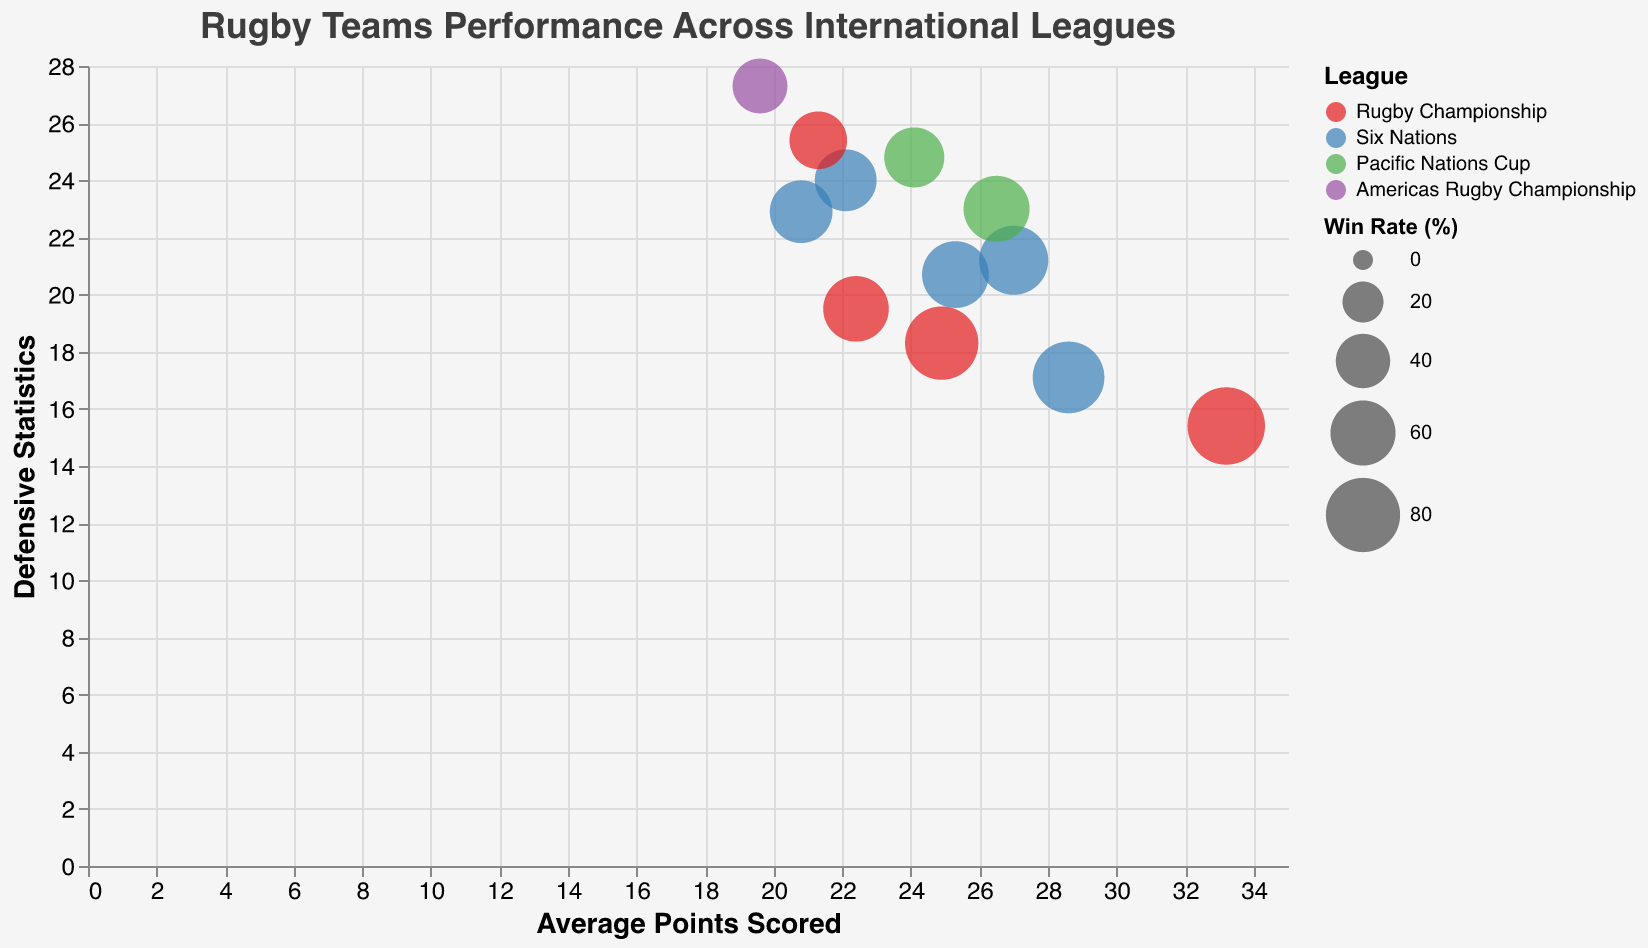What's the title of the chart? The title of the chart is usually located at the top. In this case, it is clearly labeled.
Answer: Rugby Teams Performance Across International Leagues Which league does the color red represent in the chart? The chart uses specific colors to indicate different leagues. Red represents one of these leagues according to the legend.
Answer: Rugby Championship What is the average win rate of teams in the Six Nations league displayed on the chart? To find the average win rate, sum the win rates of all the teams in the Six Nations league and divide by the number of teams: (74.2 + 63.5 + 68.4 + 55.3 + 53.5)/5 = 62.98%.
Answer: 62.98% Which team has the highest win rate and what is it? The largest bubble will indicate the highest win rate. Based on the data, this team is the New Zealand All Blacks.
Answer: New Zealand All Blacks with 87.5% Compare the defensive statistics of the Fiji Flying Fijians and the England Red Roses. Which team has better defensive statistics? The defensive statistics are shown on the y-axis. Lower values indicate better defense. Fiji Flying Fijians have 24.8, while England Red Roses have 17.1. Therefore, England Red Roses have better defensive statistics.
Answer: England Red Roses What is the relationship between win rate and average points scored for the New Zealand All Blacks? Identify the bubble for New Zealand All Blacks, check its position on the x-axis (average points scored) and its size (win rate). The New Zealand All Blacks have a win rate of 87.5% and average points scored of 33.2, suggesting a high win rate correlates with high average points scored.
Answer: Positive correlation Which team from the Americas Rugby Championship is represented in the chart and what are its key performance metrics? The chart legend and tooltips will help identify the team. The team is the United States Eagles. Their performance metrics are a win rate of 40.8%, average points scored of 19.6, and defensive statistics of 27.3.
Answer: United States Eagles: Win Rate 40.8%, Avg. Points Scored 19.6, Defensive Stats 27.3 Among the teams in the Pacific Nations Cup, which team scores the most average points? Check the average points scored (x-axis) for the teams in the Pacific Nations Cup. Japan Brave Blossoms have 26.5, higher than Fiji Flying Fijians' 24.1.
Answer: Japan Brave Blossoms Based on the visual representation, how does the win rate affect bubble size in the chart? Larger win rates are represented by larger bubble sizes. Larger bubbles indicate higher win rates, whereas smaller bubbles indicate lower win rates.
Answer: Larger win rate means larger bubble size Which team in the chart has the highest defensive statistic? The y-axis represents defensive statistics. The bubble located highest on the y-axis shows the highest defensive statistic. The United States Eagles have the highest defensive statistic at 27.3.
Answer: United States Eagles 